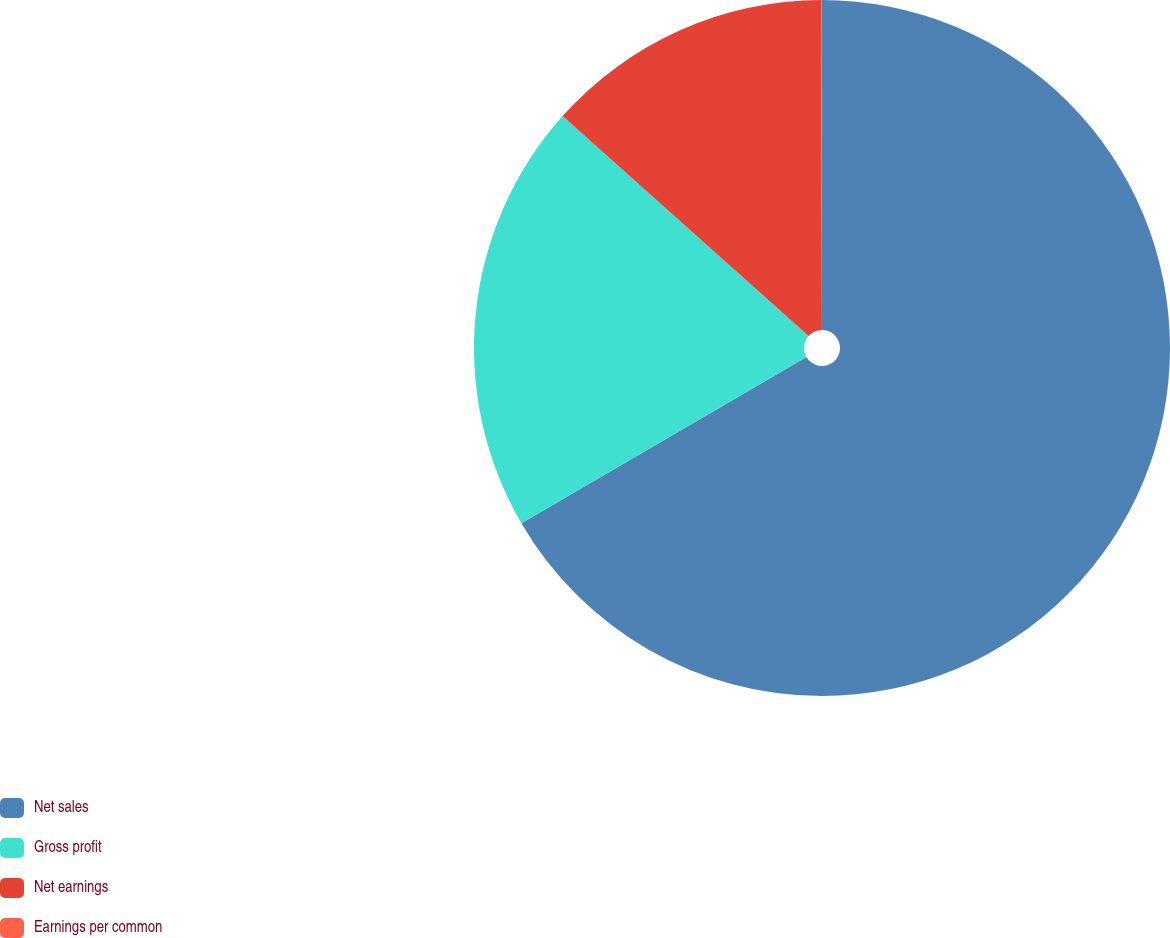Convert chart. <chart><loc_0><loc_0><loc_500><loc_500><pie_chart><fcel>Net sales<fcel>Gross profit<fcel>Net earnings<fcel>Earnings per common<nl><fcel>66.6%<fcel>20.01%<fcel>13.35%<fcel>0.04%<nl></chart> 